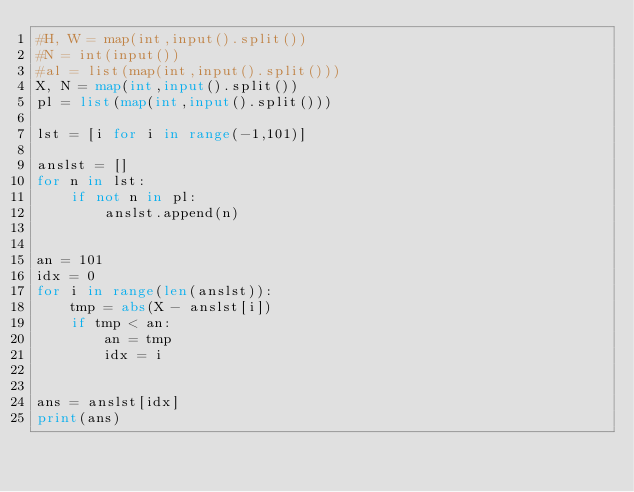Convert code to text. <code><loc_0><loc_0><loc_500><loc_500><_Python_>#H, W = map(int,input().split())
#N = int(input())
#al = list(map(int,input().split()))
X, N = map(int,input().split())
pl = list(map(int,input().split()))

lst = [i for i in range(-1,101)]

anslst = []
for n in lst:
    if not n in pl:
        anslst.append(n)


an = 101
idx = 0
for i in range(len(anslst)):
    tmp = abs(X - anslst[i])
    if tmp < an:
        an = tmp
        idx = i


ans = anslst[idx]
print(ans)</code> 